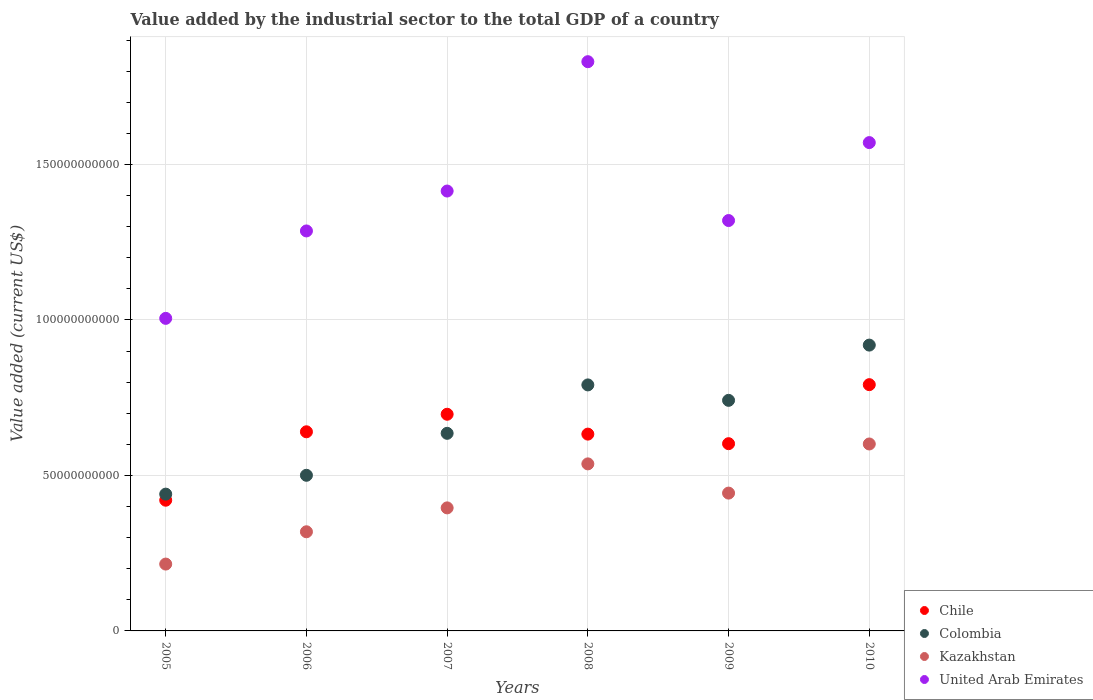What is the value added by the industrial sector to the total GDP in Chile in 2010?
Provide a succinct answer. 7.92e+1. Across all years, what is the maximum value added by the industrial sector to the total GDP in Chile?
Your answer should be very brief. 7.92e+1. Across all years, what is the minimum value added by the industrial sector to the total GDP in Kazakhstan?
Offer a very short reply. 2.15e+1. In which year was the value added by the industrial sector to the total GDP in Chile minimum?
Make the answer very short. 2005. What is the total value added by the industrial sector to the total GDP in Chile in the graph?
Your answer should be very brief. 3.78e+11. What is the difference between the value added by the industrial sector to the total GDP in United Arab Emirates in 2005 and that in 2009?
Keep it short and to the point. -3.15e+1. What is the difference between the value added by the industrial sector to the total GDP in Kazakhstan in 2010 and the value added by the industrial sector to the total GDP in Colombia in 2009?
Offer a terse response. -1.40e+1. What is the average value added by the industrial sector to the total GDP in United Arab Emirates per year?
Offer a very short reply. 1.40e+11. In the year 2010, what is the difference between the value added by the industrial sector to the total GDP in Kazakhstan and value added by the industrial sector to the total GDP in United Arab Emirates?
Keep it short and to the point. -9.69e+1. In how many years, is the value added by the industrial sector to the total GDP in Colombia greater than 170000000000 US$?
Give a very brief answer. 0. What is the ratio of the value added by the industrial sector to the total GDP in United Arab Emirates in 2007 to that in 2008?
Ensure brevity in your answer.  0.77. What is the difference between the highest and the second highest value added by the industrial sector to the total GDP in United Arab Emirates?
Your answer should be compact. 2.60e+1. What is the difference between the highest and the lowest value added by the industrial sector to the total GDP in Kazakhstan?
Your answer should be very brief. 3.86e+1. In how many years, is the value added by the industrial sector to the total GDP in United Arab Emirates greater than the average value added by the industrial sector to the total GDP in United Arab Emirates taken over all years?
Provide a succinct answer. 3. Is the sum of the value added by the industrial sector to the total GDP in Chile in 2006 and 2008 greater than the maximum value added by the industrial sector to the total GDP in United Arab Emirates across all years?
Make the answer very short. No. Is it the case that in every year, the sum of the value added by the industrial sector to the total GDP in Colombia and value added by the industrial sector to the total GDP in United Arab Emirates  is greater than the sum of value added by the industrial sector to the total GDP in Chile and value added by the industrial sector to the total GDP in Kazakhstan?
Make the answer very short. No. Is it the case that in every year, the sum of the value added by the industrial sector to the total GDP in United Arab Emirates and value added by the industrial sector to the total GDP in Kazakhstan  is greater than the value added by the industrial sector to the total GDP in Colombia?
Provide a succinct answer. Yes. Does the value added by the industrial sector to the total GDP in United Arab Emirates monotonically increase over the years?
Provide a short and direct response. No. Is the value added by the industrial sector to the total GDP in Colombia strictly less than the value added by the industrial sector to the total GDP in Kazakhstan over the years?
Your answer should be very brief. No. How many dotlines are there?
Keep it short and to the point. 4. How many years are there in the graph?
Keep it short and to the point. 6. What is the difference between two consecutive major ticks on the Y-axis?
Your answer should be compact. 5.00e+1. Are the values on the major ticks of Y-axis written in scientific E-notation?
Give a very brief answer. No. Does the graph contain grids?
Your response must be concise. Yes. Where does the legend appear in the graph?
Your answer should be compact. Bottom right. What is the title of the graph?
Keep it short and to the point. Value added by the industrial sector to the total GDP of a country. What is the label or title of the X-axis?
Your answer should be very brief. Years. What is the label or title of the Y-axis?
Make the answer very short. Value added (current US$). What is the Value added (current US$) in Chile in 2005?
Ensure brevity in your answer.  4.20e+1. What is the Value added (current US$) of Colombia in 2005?
Your answer should be very brief. 4.40e+1. What is the Value added (current US$) of Kazakhstan in 2005?
Provide a succinct answer. 2.15e+1. What is the Value added (current US$) of United Arab Emirates in 2005?
Your answer should be compact. 1.01e+11. What is the Value added (current US$) of Chile in 2006?
Your answer should be compact. 6.40e+1. What is the Value added (current US$) of Colombia in 2006?
Give a very brief answer. 5.00e+1. What is the Value added (current US$) in Kazakhstan in 2006?
Offer a very short reply. 3.19e+1. What is the Value added (current US$) of United Arab Emirates in 2006?
Ensure brevity in your answer.  1.29e+11. What is the Value added (current US$) of Chile in 2007?
Provide a short and direct response. 6.97e+1. What is the Value added (current US$) of Colombia in 2007?
Ensure brevity in your answer.  6.35e+1. What is the Value added (current US$) of Kazakhstan in 2007?
Ensure brevity in your answer.  3.96e+1. What is the Value added (current US$) in United Arab Emirates in 2007?
Keep it short and to the point. 1.41e+11. What is the Value added (current US$) of Chile in 2008?
Give a very brief answer. 6.33e+1. What is the Value added (current US$) in Colombia in 2008?
Give a very brief answer. 7.91e+1. What is the Value added (current US$) in Kazakhstan in 2008?
Your response must be concise. 5.37e+1. What is the Value added (current US$) of United Arab Emirates in 2008?
Offer a very short reply. 1.83e+11. What is the Value added (current US$) in Chile in 2009?
Offer a very short reply. 6.02e+1. What is the Value added (current US$) of Colombia in 2009?
Give a very brief answer. 7.41e+1. What is the Value added (current US$) in Kazakhstan in 2009?
Make the answer very short. 4.43e+1. What is the Value added (current US$) of United Arab Emirates in 2009?
Ensure brevity in your answer.  1.32e+11. What is the Value added (current US$) in Chile in 2010?
Keep it short and to the point. 7.92e+1. What is the Value added (current US$) in Colombia in 2010?
Offer a terse response. 9.19e+1. What is the Value added (current US$) in Kazakhstan in 2010?
Your response must be concise. 6.01e+1. What is the Value added (current US$) in United Arab Emirates in 2010?
Offer a very short reply. 1.57e+11. Across all years, what is the maximum Value added (current US$) in Chile?
Offer a very short reply. 7.92e+1. Across all years, what is the maximum Value added (current US$) of Colombia?
Make the answer very short. 9.19e+1. Across all years, what is the maximum Value added (current US$) in Kazakhstan?
Make the answer very short. 6.01e+1. Across all years, what is the maximum Value added (current US$) in United Arab Emirates?
Provide a succinct answer. 1.83e+11. Across all years, what is the minimum Value added (current US$) of Chile?
Provide a succinct answer. 4.20e+1. Across all years, what is the minimum Value added (current US$) of Colombia?
Provide a succinct answer. 4.40e+1. Across all years, what is the minimum Value added (current US$) of Kazakhstan?
Offer a very short reply. 2.15e+1. Across all years, what is the minimum Value added (current US$) in United Arab Emirates?
Your answer should be very brief. 1.01e+11. What is the total Value added (current US$) of Chile in the graph?
Ensure brevity in your answer.  3.78e+11. What is the total Value added (current US$) in Colombia in the graph?
Your answer should be compact. 4.03e+11. What is the total Value added (current US$) of Kazakhstan in the graph?
Ensure brevity in your answer.  2.51e+11. What is the total Value added (current US$) of United Arab Emirates in the graph?
Provide a short and direct response. 8.43e+11. What is the difference between the Value added (current US$) of Chile in 2005 and that in 2006?
Provide a succinct answer. -2.20e+1. What is the difference between the Value added (current US$) of Colombia in 2005 and that in 2006?
Provide a succinct answer. -6.06e+09. What is the difference between the Value added (current US$) of Kazakhstan in 2005 and that in 2006?
Offer a very short reply. -1.04e+1. What is the difference between the Value added (current US$) of United Arab Emirates in 2005 and that in 2006?
Ensure brevity in your answer.  -2.81e+1. What is the difference between the Value added (current US$) of Chile in 2005 and that in 2007?
Offer a terse response. -2.76e+1. What is the difference between the Value added (current US$) of Colombia in 2005 and that in 2007?
Ensure brevity in your answer.  -1.96e+1. What is the difference between the Value added (current US$) of Kazakhstan in 2005 and that in 2007?
Make the answer very short. -1.81e+1. What is the difference between the Value added (current US$) of United Arab Emirates in 2005 and that in 2007?
Ensure brevity in your answer.  -4.09e+1. What is the difference between the Value added (current US$) of Chile in 2005 and that in 2008?
Your answer should be compact. -2.13e+1. What is the difference between the Value added (current US$) in Colombia in 2005 and that in 2008?
Make the answer very short. -3.51e+1. What is the difference between the Value added (current US$) in Kazakhstan in 2005 and that in 2008?
Keep it short and to the point. -3.22e+1. What is the difference between the Value added (current US$) in United Arab Emirates in 2005 and that in 2008?
Offer a terse response. -8.25e+1. What is the difference between the Value added (current US$) in Chile in 2005 and that in 2009?
Offer a very short reply. -1.82e+1. What is the difference between the Value added (current US$) of Colombia in 2005 and that in 2009?
Keep it short and to the point. -3.02e+1. What is the difference between the Value added (current US$) in Kazakhstan in 2005 and that in 2009?
Provide a short and direct response. -2.28e+1. What is the difference between the Value added (current US$) in United Arab Emirates in 2005 and that in 2009?
Offer a terse response. -3.15e+1. What is the difference between the Value added (current US$) of Chile in 2005 and that in 2010?
Provide a short and direct response. -3.72e+1. What is the difference between the Value added (current US$) of Colombia in 2005 and that in 2010?
Offer a very short reply. -4.79e+1. What is the difference between the Value added (current US$) in Kazakhstan in 2005 and that in 2010?
Your answer should be compact. -3.86e+1. What is the difference between the Value added (current US$) of United Arab Emirates in 2005 and that in 2010?
Offer a very short reply. -5.65e+1. What is the difference between the Value added (current US$) in Chile in 2006 and that in 2007?
Make the answer very short. -5.64e+09. What is the difference between the Value added (current US$) of Colombia in 2006 and that in 2007?
Your answer should be very brief. -1.35e+1. What is the difference between the Value added (current US$) in Kazakhstan in 2006 and that in 2007?
Provide a succinct answer. -7.68e+09. What is the difference between the Value added (current US$) of United Arab Emirates in 2006 and that in 2007?
Ensure brevity in your answer.  -1.28e+1. What is the difference between the Value added (current US$) of Chile in 2006 and that in 2008?
Provide a short and direct response. 7.50e+08. What is the difference between the Value added (current US$) of Colombia in 2006 and that in 2008?
Your response must be concise. -2.91e+1. What is the difference between the Value added (current US$) of Kazakhstan in 2006 and that in 2008?
Keep it short and to the point. -2.18e+1. What is the difference between the Value added (current US$) of United Arab Emirates in 2006 and that in 2008?
Ensure brevity in your answer.  -5.44e+1. What is the difference between the Value added (current US$) in Chile in 2006 and that in 2009?
Make the answer very short. 3.82e+09. What is the difference between the Value added (current US$) of Colombia in 2006 and that in 2009?
Provide a short and direct response. -2.41e+1. What is the difference between the Value added (current US$) of Kazakhstan in 2006 and that in 2009?
Your response must be concise. -1.24e+1. What is the difference between the Value added (current US$) in United Arab Emirates in 2006 and that in 2009?
Make the answer very short. -3.35e+09. What is the difference between the Value added (current US$) in Chile in 2006 and that in 2010?
Offer a terse response. -1.52e+1. What is the difference between the Value added (current US$) of Colombia in 2006 and that in 2010?
Ensure brevity in your answer.  -4.19e+1. What is the difference between the Value added (current US$) in Kazakhstan in 2006 and that in 2010?
Your answer should be very brief. -2.82e+1. What is the difference between the Value added (current US$) of United Arab Emirates in 2006 and that in 2010?
Provide a succinct answer. -2.84e+1. What is the difference between the Value added (current US$) of Chile in 2007 and that in 2008?
Offer a terse response. 6.39e+09. What is the difference between the Value added (current US$) in Colombia in 2007 and that in 2008?
Ensure brevity in your answer.  -1.56e+1. What is the difference between the Value added (current US$) in Kazakhstan in 2007 and that in 2008?
Give a very brief answer. -1.41e+1. What is the difference between the Value added (current US$) in United Arab Emirates in 2007 and that in 2008?
Offer a terse response. -4.16e+1. What is the difference between the Value added (current US$) of Chile in 2007 and that in 2009?
Your response must be concise. 9.46e+09. What is the difference between the Value added (current US$) in Colombia in 2007 and that in 2009?
Ensure brevity in your answer.  -1.06e+1. What is the difference between the Value added (current US$) in Kazakhstan in 2007 and that in 2009?
Your answer should be compact. -4.75e+09. What is the difference between the Value added (current US$) in United Arab Emirates in 2007 and that in 2009?
Offer a very short reply. 9.48e+09. What is the difference between the Value added (current US$) in Chile in 2007 and that in 2010?
Your answer should be compact. -9.52e+09. What is the difference between the Value added (current US$) in Colombia in 2007 and that in 2010?
Provide a short and direct response. -2.84e+1. What is the difference between the Value added (current US$) of Kazakhstan in 2007 and that in 2010?
Make the answer very short. -2.06e+1. What is the difference between the Value added (current US$) of United Arab Emirates in 2007 and that in 2010?
Your answer should be compact. -1.56e+1. What is the difference between the Value added (current US$) in Chile in 2008 and that in 2009?
Ensure brevity in your answer.  3.07e+09. What is the difference between the Value added (current US$) in Colombia in 2008 and that in 2009?
Keep it short and to the point. 4.96e+09. What is the difference between the Value added (current US$) in Kazakhstan in 2008 and that in 2009?
Your answer should be very brief. 9.40e+09. What is the difference between the Value added (current US$) of United Arab Emirates in 2008 and that in 2009?
Provide a short and direct response. 5.11e+1. What is the difference between the Value added (current US$) of Chile in 2008 and that in 2010?
Your answer should be very brief. -1.59e+1. What is the difference between the Value added (current US$) of Colombia in 2008 and that in 2010?
Provide a succinct answer. -1.28e+1. What is the difference between the Value added (current US$) in Kazakhstan in 2008 and that in 2010?
Ensure brevity in your answer.  -6.40e+09. What is the difference between the Value added (current US$) of United Arab Emirates in 2008 and that in 2010?
Your answer should be very brief. 2.60e+1. What is the difference between the Value added (current US$) of Chile in 2009 and that in 2010?
Your answer should be very brief. -1.90e+1. What is the difference between the Value added (current US$) in Colombia in 2009 and that in 2010?
Your response must be concise. -1.78e+1. What is the difference between the Value added (current US$) in Kazakhstan in 2009 and that in 2010?
Your response must be concise. -1.58e+1. What is the difference between the Value added (current US$) in United Arab Emirates in 2009 and that in 2010?
Keep it short and to the point. -2.51e+1. What is the difference between the Value added (current US$) in Chile in 2005 and the Value added (current US$) in Colombia in 2006?
Your answer should be compact. -8.01e+09. What is the difference between the Value added (current US$) of Chile in 2005 and the Value added (current US$) of Kazakhstan in 2006?
Provide a succinct answer. 1.01e+1. What is the difference between the Value added (current US$) in Chile in 2005 and the Value added (current US$) in United Arab Emirates in 2006?
Ensure brevity in your answer.  -8.66e+1. What is the difference between the Value added (current US$) in Colombia in 2005 and the Value added (current US$) in Kazakhstan in 2006?
Offer a terse response. 1.21e+1. What is the difference between the Value added (current US$) of Colombia in 2005 and the Value added (current US$) of United Arab Emirates in 2006?
Provide a succinct answer. -8.46e+1. What is the difference between the Value added (current US$) in Kazakhstan in 2005 and the Value added (current US$) in United Arab Emirates in 2006?
Provide a short and direct response. -1.07e+11. What is the difference between the Value added (current US$) of Chile in 2005 and the Value added (current US$) of Colombia in 2007?
Your answer should be very brief. -2.15e+1. What is the difference between the Value added (current US$) in Chile in 2005 and the Value added (current US$) in Kazakhstan in 2007?
Provide a short and direct response. 2.47e+09. What is the difference between the Value added (current US$) in Chile in 2005 and the Value added (current US$) in United Arab Emirates in 2007?
Give a very brief answer. -9.94e+1. What is the difference between the Value added (current US$) in Colombia in 2005 and the Value added (current US$) in Kazakhstan in 2007?
Offer a terse response. 4.42e+09. What is the difference between the Value added (current US$) of Colombia in 2005 and the Value added (current US$) of United Arab Emirates in 2007?
Give a very brief answer. -9.75e+1. What is the difference between the Value added (current US$) in Kazakhstan in 2005 and the Value added (current US$) in United Arab Emirates in 2007?
Provide a succinct answer. -1.20e+11. What is the difference between the Value added (current US$) of Chile in 2005 and the Value added (current US$) of Colombia in 2008?
Provide a succinct answer. -3.71e+1. What is the difference between the Value added (current US$) of Chile in 2005 and the Value added (current US$) of Kazakhstan in 2008?
Ensure brevity in your answer.  -1.17e+1. What is the difference between the Value added (current US$) of Chile in 2005 and the Value added (current US$) of United Arab Emirates in 2008?
Keep it short and to the point. -1.41e+11. What is the difference between the Value added (current US$) in Colombia in 2005 and the Value added (current US$) in Kazakhstan in 2008?
Provide a succinct answer. -9.73e+09. What is the difference between the Value added (current US$) in Colombia in 2005 and the Value added (current US$) in United Arab Emirates in 2008?
Your answer should be very brief. -1.39e+11. What is the difference between the Value added (current US$) in Kazakhstan in 2005 and the Value added (current US$) in United Arab Emirates in 2008?
Your response must be concise. -1.62e+11. What is the difference between the Value added (current US$) in Chile in 2005 and the Value added (current US$) in Colombia in 2009?
Give a very brief answer. -3.21e+1. What is the difference between the Value added (current US$) of Chile in 2005 and the Value added (current US$) of Kazakhstan in 2009?
Offer a terse response. -2.29e+09. What is the difference between the Value added (current US$) of Chile in 2005 and the Value added (current US$) of United Arab Emirates in 2009?
Ensure brevity in your answer.  -8.99e+1. What is the difference between the Value added (current US$) in Colombia in 2005 and the Value added (current US$) in Kazakhstan in 2009?
Offer a very short reply. -3.32e+08. What is the difference between the Value added (current US$) in Colombia in 2005 and the Value added (current US$) in United Arab Emirates in 2009?
Keep it short and to the point. -8.80e+1. What is the difference between the Value added (current US$) in Kazakhstan in 2005 and the Value added (current US$) in United Arab Emirates in 2009?
Offer a very short reply. -1.10e+11. What is the difference between the Value added (current US$) of Chile in 2005 and the Value added (current US$) of Colombia in 2010?
Provide a short and direct response. -4.99e+1. What is the difference between the Value added (current US$) in Chile in 2005 and the Value added (current US$) in Kazakhstan in 2010?
Give a very brief answer. -1.81e+1. What is the difference between the Value added (current US$) of Chile in 2005 and the Value added (current US$) of United Arab Emirates in 2010?
Provide a succinct answer. -1.15e+11. What is the difference between the Value added (current US$) in Colombia in 2005 and the Value added (current US$) in Kazakhstan in 2010?
Keep it short and to the point. -1.61e+1. What is the difference between the Value added (current US$) in Colombia in 2005 and the Value added (current US$) in United Arab Emirates in 2010?
Offer a terse response. -1.13e+11. What is the difference between the Value added (current US$) in Kazakhstan in 2005 and the Value added (current US$) in United Arab Emirates in 2010?
Give a very brief answer. -1.36e+11. What is the difference between the Value added (current US$) of Chile in 2006 and the Value added (current US$) of Colombia in 2007?
Your answer should be very brief. 4.94e+08. What is the difference between the Value added (current US$) of Chile in 2006 and the Value added (current US$) of Kazakhstan in 2007?
Offer a very short reply. 2.45e+1. What is the difference between the Value added (current US$) in Chile in 2006 and the Value added (current US$) in United Arab Emirates in 2007?
Your answer should be very brief. -7.74e+1. What is the difference between the Value added (current US$) in Colombia in 2006 and the Value added (current US$) in Kazakhstan in 2007?
Offer a terse response. 1.05e+1. What is the difference between the Value added (current US$) of Colombia in 2006 and the Value added (current US$) of United Arab Emirates in 2007?
Keep it short and to the point. -9.14e+1. What is the difference between the Value added (current US$) in Kazakhstan in 2006 and the Value added (current US$) in United Arab Emirates in 2007?
Offer a terse response. -1.10e+11. What is the difference between the Value added (current US$) in Chile in 2006 and the Value added (current US$) in Colombia in 2008?
Keep it short and to the point. -1.51e+1. What is the difference between the Value added (current US$) in Chile in 2006 and the Value added (current US$) in Kazakhstan in 2008?
Your answer should be compact. 1.03e+1. What is the difference between the Value added (current US$) of Chile in 2006 and the Value added (current US$) of United Arab Emirates in 2008?
Offer a very short reply. -1.19e+11. What is the difference between the Value added (current US$) in Colombia in 2006 and the Value added (current US$) in Kazakhstan in 2008?
Your response must be concise. -3.67e+09. What is the difference between the Value added (current US$) in Colombia in 2006 and the Value added (current US$) in United Arab Emirates in 2008?
Make the answer very short. -1.33e+11. What is the difference between the Value added (current US$) in Kazakhstan in 2006 and the Value added (current US$) in United Arab Emirates in 2008?
Keep it short and to the point. -1.51e+11. What is the difference between the Value added (current US$) of Chile in 2006 and the Value added (current US$) of Colombia in 2009?
Provide a short and direct response. -1.01e+1. What is the difference between the Value added (current US$) of Chile in 2006 and the Value added (current US$) of Kazakhstan in 2009?
Provide a succinct answer. 1.97e+1. What is the difference between the Value added (current US$) of Chile in 2006 and the Value added (current US$) of United Arab Emirates in 2009?
Offer a very short reply. -6.79e+1. What is the difference between the Value added (current US$) in Colombia in 2006 and the Value added (current US$) in Kazakhstan in 2009?
Ensure brevity in your answer.  5.73e+09. What is the difference between the Value added (current US$) of Colombia in 2006 and the Value added (current US$) of United Arab Emirates in 2009?
Make the answer very short. -8.19e+1. What is the difference between the Value added (current US$) of Kazakhstan in 2006 and the Value added (current US$) of United Arab Emirates in 2009?
Offer a terse response. -1.00e+11. What is the difference between the Value added (current US$) in Chile in 2006 and the Value added (current US$) in Colombia in 2010?
Provide a short and direct response. -2.79e+1. What is the difference between the Value added (current US$) in Chile in 2006 and the Value added (current US$) in Kazakhstan in 2010?
Provide a succinct answer. 3.92e+09. What is the difference between the Value added (current US$) of Chile in 2006 and the Value added (current US$) of United Arab Emirates in 2010?
Your response must be concise. -9.30e+1. What is the difference between the Value added (current US$) of Colombia in 2006 and the Value added (current US$) of Kazakhstan in 2010?
Your response must be concise. -1.01e+1. What is the difference between the Value added (current US$) of Colombia in 2006 and the Value added (current US$) of United Arab Emirates in 2010?
Offer a terse response. -1.07e+11. What is the difference between the Value added (current US$) in Kazakhstan in 2006 and the Value added (current US$) in United Arab Emirates in 2010?
Make the answer very short. -1.25e+11. What is the difference between the Value added (current US$) in Chile in 2007 and the Value added (current US$) in Colombia in 2008?
Your response must be concise. -9.43e+09. What is the difference between the Value added (current US$) in Chile in 2007 and the Value added (current US$) in Kazakhstan in 2008?
Your answer should be compact. 1.60e+1. What is the difference between the Value added (current US$) in Chile in 2007 and the Value added (current US$) in United Arab Emirates in 2008?
Offer a very short reply. -1.13e+11. What is the difference between the Value added (current US$) of Colombia in 2007 and the Value added (current US$) of Kazakhstan in 2008?
Offer a terse response. 9.82e+09. What is the difference between the Value added (current US$) in Colombia in 2007 and the Value added (current US$) in United Arab Emirates in 2008?
Provide a short and direct response. -1.19e+11. What is the difference between the Value added (current US$) of Kazakhstan in 2007 and the Value added (current US$) of United Arab Emirates in 2008?
Your answer should be very brief. -1.43e+11. What is the difference between the Value added (current US$) of Chile in 2007 and the Value added (current US$) of Colombia in 2009?
Ensure brevity in your answer.  -4.47e+09. What is the difference between the Value added (current US$) in Chile in 2007 and the Value added (current US$) in Kazakhstan in 2009?
Your answer should be compact. 2.54e+1. What is the difference between the Value added (current US$) in Chile in 2007 and the Value added (current US$) in United Arab Emirates in 2009?
Offer a terse response. -6.23e+1. What is the difference between the Value added (current US$) in Colombia in 2007 and the Value added (current US$) in Kazakhstan in 2009?
Make the answer very short. 1.92e+1. What is the difference between the Value added (current US$) in Colombia in 2007 and the Value added (current US$) in United Arab Emirates in 2009?
Give a very brief answer. -6.84e+1. What is the difference between the Value added (current US$) of Kazakhstan in 2007 and the Value added (current US$) of United Arab Emirates in 2009?
Keep it short and to the point. -9.24e+1. What is the difference between the Value added (current US$) in Chile in 2007 and the Value added (current US$) in Colombia in 2010?
Offer a very short reply. -2.22e+1. What is the difference between the Value added (current US$) of Chile in 2007 and the Value added (current US$) of Kazakhstan in 2010?
Make the answer very short. 9.56e+09. What is the difference between the Value added (current US$) in Chile in 2007 and the Value added (current US$) in United Arab Emirates in 2010?
Give a very brief answer. -8.74e+1. What is the difference between the Value added (current US$) of Colombia in 2007 and the Value added (current US$) of Kazakhstan in 2010?
Give a very brief answer. 3.42e+09. What is the difference between the Value added (current US$) in Colombia in 2007 and the Value added (current US$) in United Arab Emirates in 2010?
Provide a short and direct response. -9.35e+1. What is the difference between the Value added (current US$) of Kazakhstan in 2007 and the Value added (current US$) of United Arab Emirates in 2010?
Your answer should be very brief. -1.17e+11. What is the difference between the Value added (current US$) of Chile in 2008 and the Value added (current US$) of Colombia in 2009?
Your response must be concise. -1.09e+1. What is the difference between the Value added (current US$) in Chile in 2008 and the Value added (current US$) in Kazakhstan in 2009?
Provide a short and direct response. 1.90e+1. What is the difference between the Value added (current US$) in Chile in 2008 and the Value added (current US$) in United Arab Emirates in 2009?
Provide a short and direct response. -6.87e+1. What is the difference between the Value added (current US$) in Colombia in 2008 and the Value added (current US$) in Kazakhstan in 2009?
Your response must be concise. 3.48e+1. What is the difference between the Value added (current US$) in Colombia in 2008 and the Value added (current US$) in United Arab Emirates in 2009?
Ensure brevity in your answer.  -5.29e+1. What is the difference between the Value added (current US$) of Kazakhstan in 2008 and the Value added (current US$) of United Arab Emirates in 2009?
Provide a succinct answer. -7.82e+1. What is the difference between the Value added (current US$) of Chile in 2008 and the Value added (current US$) of Colombia in 2010?
Give a very brief answer. -2.86e+1. What is the difference between the Value added (current US$) of Chile in 2008 and the Value added (current US$) of Kazakhstan in 2010?
Keep it short and to the point. 3.17e+09. What is the difference between the Value added (current US$) of Chile in 2008 and the Value added (current US$) of United Arab Emirates in 2010?
Your answer should be very brief. -9.37e+1. What is the difference between the Value added (current US$) of Colombia in 2008 and the Value added (current US$) of Kazakhstan in 2010?
Make the answer very short. 1.90e+1. What is the difference between the Value added (current US$) in Colombia in 2008 and the Value added (current US$) in United Arab Emirates in 2010?
Your answer should be compact. -7.79e+1. What is the difference between the Value added (current US$) of Kazakhstan in 2008 and the Value added (current US$) of United Arab Emirates in 2010?
Offer a terse response. -1.03e+11. What is the difference between the Value added (current US$) of Chile in 2009 and the Value added (current US$) of Colombia in 2010?
Offer a very short reply. -3.17e+1. What is the difference between the Value added (current US$) in Chile in 2009 and the Value added (current US$) in Kazakhstan in 2010?
Your answer should be compact. 9.53e+07. What is the difference between the Value added (current US$) in Chile in 2009 and the Value added (current US$) in United Arab Emirates in 2010?
Make the answer very short. -9.68e+1. What is the difference between the Value added (current US$) in Colombia in 2009 and the Value added (current US$) in Kazakhstan in 2010?
Ensure brevity in your answer.  1.40e+1. What is the difference between the Value added (current US$) of Colombia in 2009 and the Value added (current US$) of United Arab Emirates in 2010?
Provide a short and direct response. -8.29e+1. What is the difference between the Value added (current US$) of Kazakhstan in 2009 and the Value added (current US$) of United Arab Emirates in 2010?
Make the answer very short. -1.13e+11. What is the average Value added (current US$) of Chile per year?
Make the answer very short. 6.31e+1. What is the average Value added (current US$) of Colombia per year?
Keep it short and to the point. 6.71e+1. What is the average Value added (current US$) in Kazakhstan per year?
Your answer should be compact. 4.18e+1. What is the average Value added (current US$) of United Arab Emirates per year?
Your answer should be compact. 1.40e+11. In the year 2005, what is the difference between the Value added (current US$) of Chile and Value added (current US$) of Colombia?
Provide a succinct answer. -1.95e+09. In the year 2005, what is the difference between the Value added (current US$) in Chile and Value added (current US$) in Kazakhstan?
Make the answer very short. 2.05e+1. In the year 2005, what is the difference between the Value added (current US$) in Chile and Value added (current US$) in United Arab Emirates?
Provide a short and direct response. -5.85e+1. In the year 2005, what is the difference between the Value added (current US$) of Colombia and Value added (current US$) of Kazakhstan?
Give a very brief answer. 2.25e+1. In the year 2005, what is the difference between the Value added (current US$) in Colombia and Value added (current US$) in United Arab Emirates?
Keep it short and to the point. -5.65e+1. In the year 2005, what is the difference between the Value added (current US$) of Kazakhstan and Value added (current US$) of United Arab Emirates?
Provide a succinct answer. -7.90e+1. In the year 2006, what is the difference between the Value added (current US$) of Chile and Value added (current US$) of Colombia?
Make the answer very short. 1.40e+1. In the year 2006, what is the difference between the Value added (current US$) in Chile and Value added (current US$) in Kazakhstan?
Offer a very short reply. 3.21e+1. In the year 2006, what is the difference between the Value added (current US$) in Chile and Value added (current US$) in United Arab Emirates?
Your answer should be compact. -6.46e+1. In the year 2006, what is the difference between the Value added (current US$) of Colombia and Value added (current US$) of Kazakhstan?
Your response must be concise. 1.82e+1. In the year 2006, what is the difference between the Value added (current US$) in Colombia and Value added (current US$) in United Arab Emirates?
Provide a short and direct response. -7.86e+1. In the year 2006, what is the difference between the Value added (current US$) in Kazakhstan and Value added (current US$) in United Arab Emirates?
Provide a succinct answer. -9.67e+1. In the year 2007, what is the difference between the Value added (current US$) of Chile and Value added (current US$) of Colombia?
Give a very brief answer. 6.13e+09. In the year 2007, what is the difference between the Value added (current US$) in Chile and Value added (current US$) in Kazakhstan?
Provide a succinct answer. 3.01e+1. In the year 2007, what is the difference between the Value added (current US$) of Chile and Value added (current US$) of United Arab Emirates?
Ensure brevity in your answer.  -7.18e+1. In the year 2007, what is the difference between the Value added (current US$) in Colombia and Value added (current US$) in Kazakhstan?
Provide a succinct answer. 2.40e+1. In the year 2007, what is the difference between the Value added (current US$) of Colombia and Value added (current US$) of United Arab Emirates?
Keep it short and to the point. -7.79e+1. In the year 2007, what is the difference between the Value added (current US$) in Kazakhstan and Value added (current US$) in United Arab Emirates?
Make the answer very short. -1.02e+11. In the year 2008, what is the difference between the Value added (current US$) in Chile and Value added (current US$) in Colombia?
Your answer should be compact. -1.58e+1. In the year 2008, what is the difference between the Value added (current US$) of Chile and Value added (current US$) of Kazakhstan?
Provide a succinct answer. 9.57e+09. In the year 2008, what is the difference between the Value added (current US$) in Chile and Value added (current US$) in United Arab Emirates?
Your response must be concise. -1.20e+11. In the year 2008, what is the difference between the Value added (current US$) of Colombia and Value added (current US$) of Kazakhstan?
Make the answer very short. 2.54e+1. In the year 2008, what is the difference between the Value added (current US$) of Colombia and Value added (current US$) of United Arab Emirates?
Offer a terse response. -1.04e+11. In the year 2008, what is the difference between the Value added (current US$) in Kazakhstan and Value added (current US$) in United Arab Emirates?
Provide a succinct answer. -1.29e+11. In the year 2009, what is the difference between the Value added (current US$) of Chile and Value added (current US$) of Colombia?
Your answer should be compact. -1.39e+1. In the year 2009, what is the difference between the Value added (current US$) of Chile and Value added (current US$) of Kazakhstan?
Ensure brevity in your answer.  1.59e+1. In the year 2009, what is the difference between the Value added (current US$) in Chile and Value added (current US$) in United Arab Emirates?
Offer a very short reply. -7.18e+1. In the year 2009, what is the difference between the Value added (current US$) of Colombia and Value added (current US$) of Kazakhstan?
Your answer should be very brief. 2.98e+1. In the year 2009, what is the difference between the Value added (current US$) of Colombia and Value added (current US$) of United Arab Emirates?
Your answer should be compact. -5.78e+1. In the year 2009, what is the difference between the Value added (current US$) in Kazakhstan and Value added (current US$) in United Arab Emirates?
Offer a terse response. -8.76e+1. In the year 2010, what is the difference between the Value added (current US$) of Chile and Value added (current US$) of Colombia?
Give a very brief answer. -1.27e+1. In the year 2010, what is the difference between the Value added (current US$) of Chile and Value added (current US$) of Kazakhstan?
Give a very brief answer. 1.91e+1. In the year 2010, what is the difference between the Value added (current US$) in Chile and Value added (current US$) in United Arab Emirates?
Offer a very short reply. -7.78e+1. In the year 2010, what is the difference between the Value added (current US$) in Colombia and Value added (current US$) in Kazakhstan?
Give a very brief answer. 3.18e+1. In the year 2010, what is the difference between the Value added (current US$) in Colombia and Value added (current US$) in United Arab Emirates?
Give a very brief answer. -6.51e+1. In the year 2010, what is the difference between the Value added (current US$) of Kazakhstan and Value added (current US$) of United Arab Emirates?
Your response must be concise. -9.69e+1. What is the ratio of the Value added (current US$) of Chile in 2005 to that in 2006?
Offer a very short reply. 0.66. What is the ratio of the Value added (current US$) of Colombia in 2005 to that in 2006?
Make the answer very short. 0.88. What is the ratio of the Value added (current US$) of Kazakhstan in 2005 to that in 2006?
Your response must be concise. 0.67. What is the ratio of the Value added (current US$) in United Arab Emirates in 2005 to that in 2006?
Ensure brevity in your answer.  0.78. What is the ratio of the Value added (current US$) in Chile in 2005 to that in 2007?
Provide a short and direct response. 0.6. What is the ratio of the Value added (current US$) of Colombia in 2005 to that in 2007?
Your answer should be very brief. 0.69. What is the ratio of the Value added (current US$) of Kazakhstan in 2005 to that in 2007?
Give a very brief answer. 0.54. What is the ratio of the Value added (current US$) in United Arab Emirates in 2005 to that in 2007?
Your response must be concise. 0.71. What is the ratio of the Value added (current US$) of Chile in 2005 to that in 2008?
Provide a succinct answer. 0.66. What is the ratio of the Value added (current US$) in Colombia in 2005 to that in 2008?
Ensure brevity in your answer.  0.56. What is the ratio of the Value added (current US$) of Kazakhstan in 2005 to that in 2008?
Give a very brief answer. 0.4. What is the ratio of the Value added (current US$) in United Arab Emirates in 2005 to that in 2008?
Provide a short and direct response. 0.55. What is the ratio of the Value added (current US$) of Chile in 2005 to that in 2009?
Your response must be concise. 0.7. What is the ratio of the Value added (current US$) of Colombia in 2005 to that in 2009?
Keep it short and to the point. 0.59. What is the ratio of the Value added (current US$) of Kazakhstan in 2005 to that in 2009?
Your answer should be compact. 0.48. What is the ratio of the Value added (current US$) in United Arab Emirates in 2005 to that in 2009?
Your answer should be very brief. 0.76. What is the ratio of the Value added (current US$) of Chile in 2005 to that in 2010?
Keep it short and to the point. 0.53. What is the ratio of the Value added (current US$) in Colombia in 2005 to that in 2010?
Provide a succinct answer. 0.48. What is the ratio of the Value added (current US$) of Kazakhstan in 2005 to that in 2010?
Offer a very short reply. 0.36. What is the ratio of the Value added (current US$) in United Arab Emirates in 2005 to that in 2010?
Provide a short and direct response. 0.64. What is the ratio of the Value added (current US$) of Chile in 2006 to that in 2007?
Make the answer very short. 0.92. What is the ratio of the Value added (current US$) in Colombia in 2006 to that in 2007?
Keep it short and to the point. 0.79. What is the ratio of the Value added (current US$) of Kazakhstan in 2006 to that in 2007?
Offer a terse response. 0.81. What is the ratio of the Value added (current US$) in United Arab Emirates in 2006 to that in 2007?
Provide a succinct answer. 0.91. What is the ratio of the Value added (current US$) of Chile in 2006 to that in 2008?
Offer a terse response. 1.01. What is the ratio of the Value added (current US$) of Colombia in 2006 to that in 2008?
Provide a succinct answer. 0.63. What is the ratio of the Value added (current US$) in Kazakhstan in 2006 to that in 2008?
Offer a very short reply. 0.59. What is the ratio of the Value added (current US$) of United Arab Emirates in 2006 to that in 2008?
Offer a terse response. 0.7. What is the ratio of the Value added (current US$) of Chile in 2006 to that in 2009?
Make the answer very short. 1.06. What is the ratio of the Value added (current US$) in Colombia in 2006 to that in 2009?
Make the answer very short. 0.67. What is the ratio of the Value added (current US$) of Kazakhstan in 2006 to that in 2009?
Your answer should be compact. 0.72. What is the ratio of the Value added (current US$) of United Arab Emirates in 2006 to that in 2009?
Your answer should be very brief. 0.97. What is the ratio of the Value added (current US$) in Chile in 2006 to that in 2010?
Offer a terse response. 0.81. What is the ratio of the Value added (current US$) in Colombia in 2006 to that in 2010?
Keep it short and to the point. 0.54. What is the ratio of the Value added (current US$) of Kazakhstan in 2006 to that in 2010?
Make the answer very short. 0.53. What is the ratio of the Value added (current US$) of United Arab Emirates in 2006 to that in 2010?
Your response must be concise. 0.82. What is the ratio of the Value added (current US$) in Chile in 2007 to that in 2008?
Make the answer very short. 1.1. What is the ratio of the Value added (current US$) of Colombia in 2007 to that in 2008?
Provide a succinct answer. 0.8. What is the ratio of the Value added (current US$) of Kazakhstan in 2007 to that in 2008?
Give a very brief answer. 0.74. What is the ratio of the Value added (current US$) of United Arab Emirates in 2007 to that in 2008?
Offer a terse response. 0.77. What is the ratio of the Value added (current US$) of Chile in 2007 to that in 2009?
Your answer should be compact. 1.16. What is the ratio of the Value added (current US$) of Colombia in 2007 to that in 2009?
Ensure brevity in your answer.  0.86. What is the ratio of the Value added (current US$) in Kazakhstan in 2007 to that in 2009?
Your answer should be compact. 0.89. What is the ratio of the Value added (current US$) of United Arab Emirates in 2007 to that in 2009?
Provide a short and direct response. 1.07. What is the ratio of the Value added (current US$) in Chile in 2007 to that in 2010?
Offer a terse response. 0.88. What is the ratio of the Value added (current US$) of Colombia in 2007 to that in 2010?
Ensure brevity in your answer.  0.69. What is the ratio of the Value added (current US$) in Kazakhstan in 2007 to that in 2010?
Provide a short and direct response. 0.66. What is the ratio of the Value added (current US$) of United Arab Emirates in 2007 to that in 2010?
Make the answer very short. 0.9. What is the ratio of the Value added (current US$) in Chile in 2008 to that in 2009?
Your response must be concise. 1.05. What is the ratio of the Value added (current US$) of Colombia in 2008 to that in 2009?
Ensure brevity in your answer.  1.07. What is the ratio of the Value added (current US$) in Kazakhstan in 2008 to that in 2009?
Offer a very short reply. 1.21. What is the ratio of the Value added (current US$) in United Arab Emirates in 2008 to that in 2009?
Make the answer very short. 1.39. What is the ratio of the Value added (current US$) of Chile in 2008 to that in 2010?
Provide a short and direct response. 0.8. What is the ratio of the Value added (current US$) of Colombia in 2008 to that in 2010?
Ensure brevity in your answer.  0.86. What is the ratio of the Value added (current US$) of Kazakhstan in 2008 to that in 2010?
Provide a succinct answer. 0.89. What is the ratio of the Value added (current US$) of United Arab Emirates in 2008 to that in 2010?
Keep it short and to the point. 1.17. What is the ratio of the Value added (current US$) of Chile in 2009 to that in 2010?
Provide a succinct answer. 0.76. What is the ratio of the Value added (current US$) of Colombia in 2009 to that in 2010?
Keep it short and to the point. 0.81. What is the ratio of the Value added (current US$) of Kazakhstan in 2009 to that in 2010?
Provide a succinct answer. 0.74. What is the ratio of the Value added (current US$) of United Arab Emirates in 2009 to that in 2010?
Make the answer very short. 0.84. What is the difference between the highest and the second highest Value added (current US$) in Chile?
Provide a succinct answer. 9.52e+09. What is the difference between the highest and the second highest Value added (current US$) in Colombia?
Give a very brief answer. 1.28e+1. What is the difference between the highest and the second highest Value added (current US$) of Kazakhstan?
Offer a terse response. 6.40e+09. What is the difference between the highest and the second highest Value added (current US$) in United Arab Emirates?
Provide a succinct answer. 2.60e+1. What is the difference between the highest and the lowest Value added (current US$) of Chile?
Your answer should be compact. 3.72e+1. What is the difference between the highest and the lowest Value added (current US$) in Colombia?
Ensure brevity in your answer.  4.79e+1. What is the difference between the highest and the lowest Value added (current US$) in Kazakhstan?
Offer a very short reply. 3.86e+1. What is the difference between the highest and the lowest Value added (current US$) in United Arab Emirates?
Your answer should be very brief. 8.25e+1. 